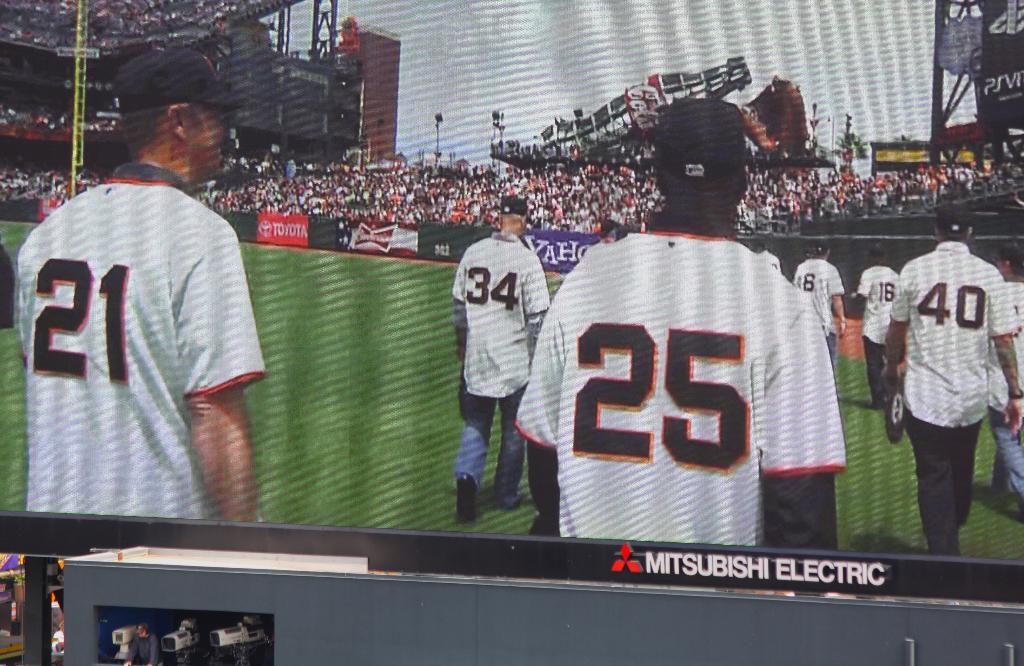How would you summarize this image in a sentence or two? In this image I can see a huge screen and in the screen I can see few persons standing, few boards, number of persons in the stadium, few trees, few light poles and the sky. 